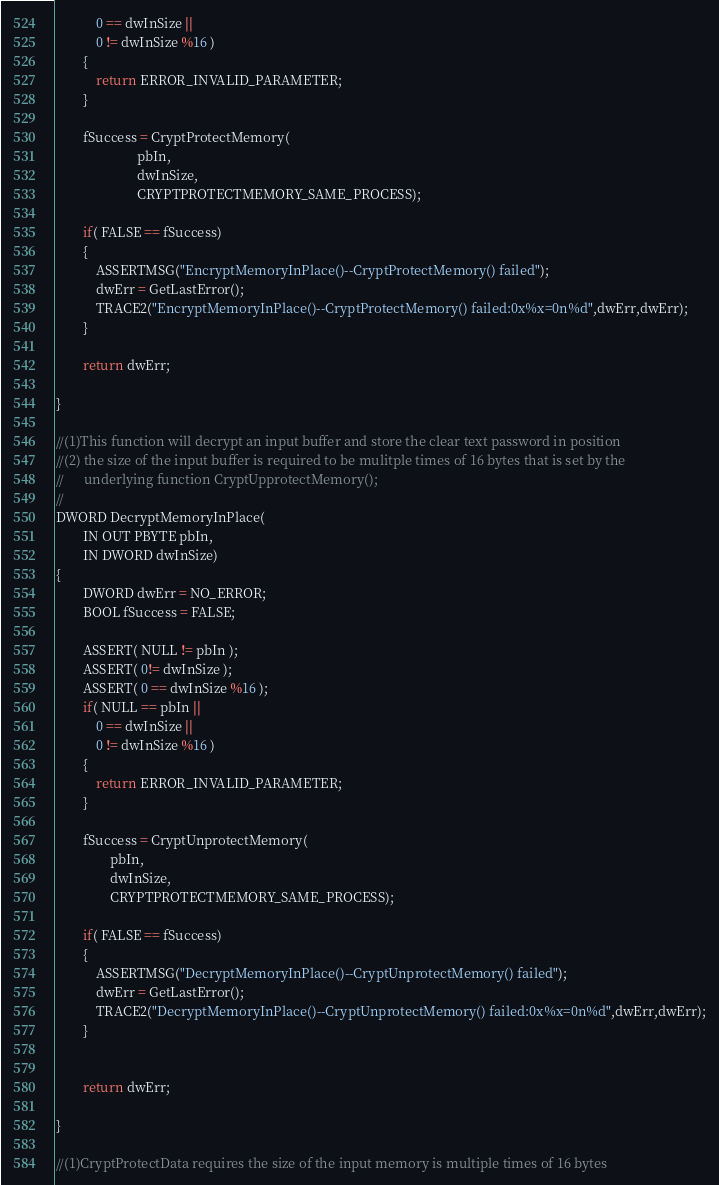<code> <loc_0><loc_0><loc_500><loc_500><_C_>            0 == dwInSize || 
            0 != dwInSize %16 )
        {
            return ERROR_INVALID_PARAMETER;
        }

        fSuccess = CryptProtectMemory(
                        pbIn,
                        dwInSize,
                        CRYPTPROTECTMEMORY_SAME_PROCESS);
                        
        if( FALSE == fSuccess)
        {
            ASSERTMSG("EncryptMemoryInPlace()--CryptProtectMemory() failed");
            dwErr = GetLastError();
            TRACE2("EncryptMemoryInPlace()--CryptProtectMemory() failed:0x%x=0n%d",dwErr,dwErr);
        }
 
        return dwErr;

}

//(1)This function will decrypt an input buffer and store the clear text password in position
//(2) the size of the input buffer is required to be mulitple times of 16 bytes that is set by the 
//      underlying function CryptUpprotectMemory();
//
DWORD DecryptMemoryInPlace(
        IN OUT PBYTE pbIn,
        IN DWORD dwInSize)
{
        DWORD dwErr = NO_ERROR;
        BOOL fSuccess = FALSE;

        ASSERT( NULL != pbIn );
        ASSERT( 0!= dwInSize );
        ASSERT( 0 == dwInSize %16 );
        if( NULL == pbIn ||
            0 == dwInSize || 
            0 != dwInSize %16 )
        {
            return ERROR_INVALID_PARAMETER;
        }

        fSuccess = CryptUnprotectMemory(
   		        pbIn,
   		        dwInSize,
   		        CRYPTPROTECTMEMORY_SAME_PROCESS);
   		        
        if( FALSE == fSuccess)
        {
            ASSERTMSG("DecryptMemoryInPlace()--CryptUnprotectMemory() failed");
            dwErr = GetLastError();
            TRACE2("DecryptMemoryInPlace()--CryptUnprotectMemory() failed:0x%x=0n%d",dwErr,dwErr);
        }


        return dwErr;

}

//(1)CryptProtectData requires the size of the input memory is multiple times of 16 bytes</code> 